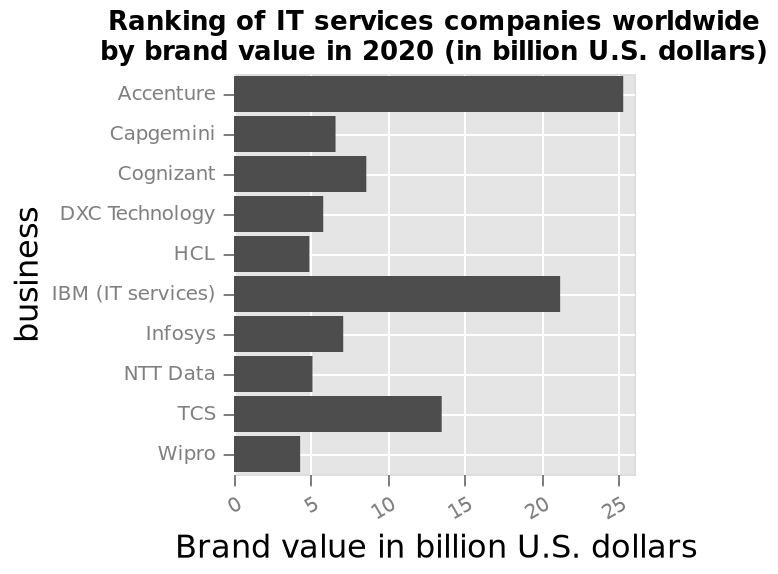<image>
please summary the statistics and relations of the chart Accenture had the greatest brand value in 2020 at more than 25 billion. Wipro had the lowest brand value in 2020. HCL and NTT data had similar brand values in 2020. What is marked on the x-axis of the bar plot? The x-axis of the bar plot is marked as "Brand value in billion U.S. dollars". Which two companies are shown on the opposite ends of the y-axis?  Accenture and Wipro are shown on the opposite ends of the y-axis. Which company had the lowest brand value in 2020?  Wipro had the lowest brand value in 2020. What is the range of values on the x-axis of the bar plot? The x-axis of the bar plot ranges from 0 to 25. Are Accenture and Wipro shown on the same end of the y-axis? No. Accenture and Wipro are shown on the opposite ends of the y-axis. Was Accenture's brand value in 2020 less than 1 billion? No.Accenture had the greatest brand value in 2020 at more than 25 billion. Wipro had the lowest brand value in 2020. HCL and NTT data had similar brand values in 2020. 